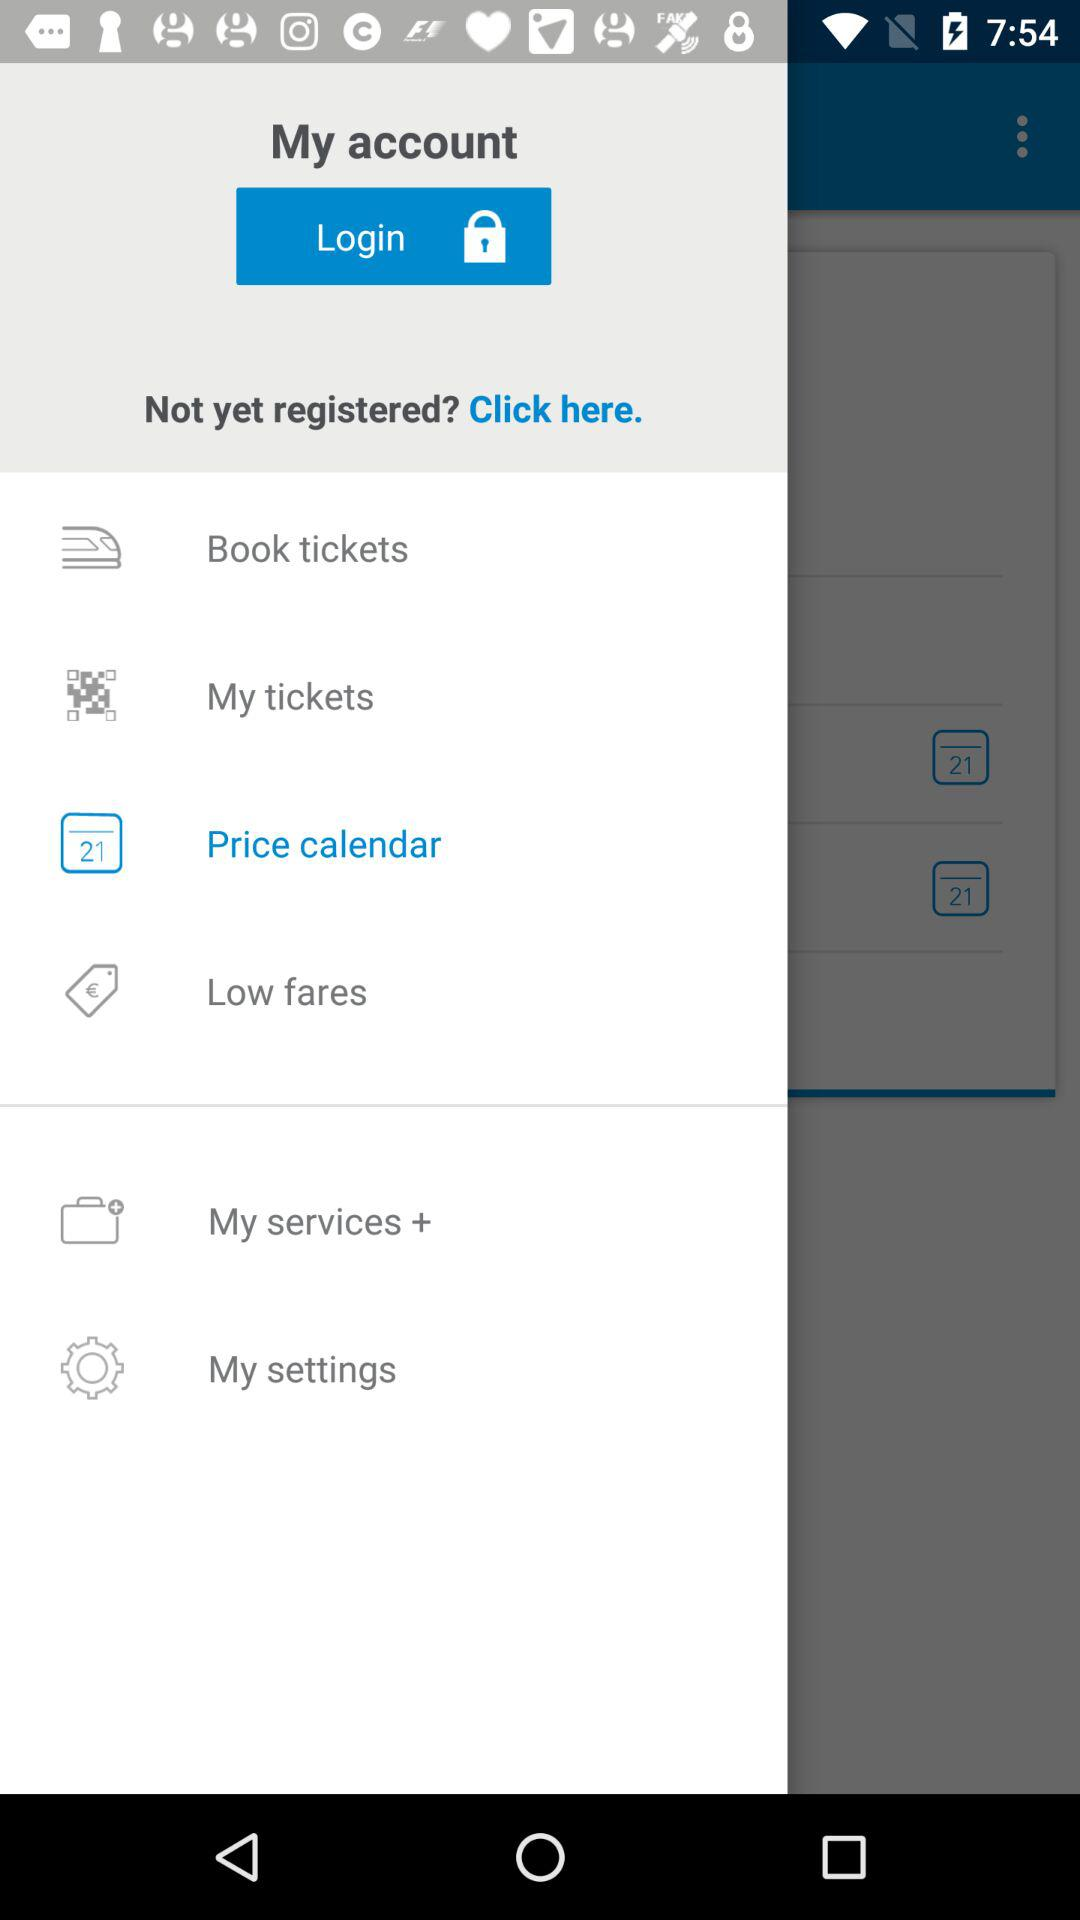How many notifications are there in "My settings"?
When the provided information is insufficient, respond with <no answer>. <no answer> 